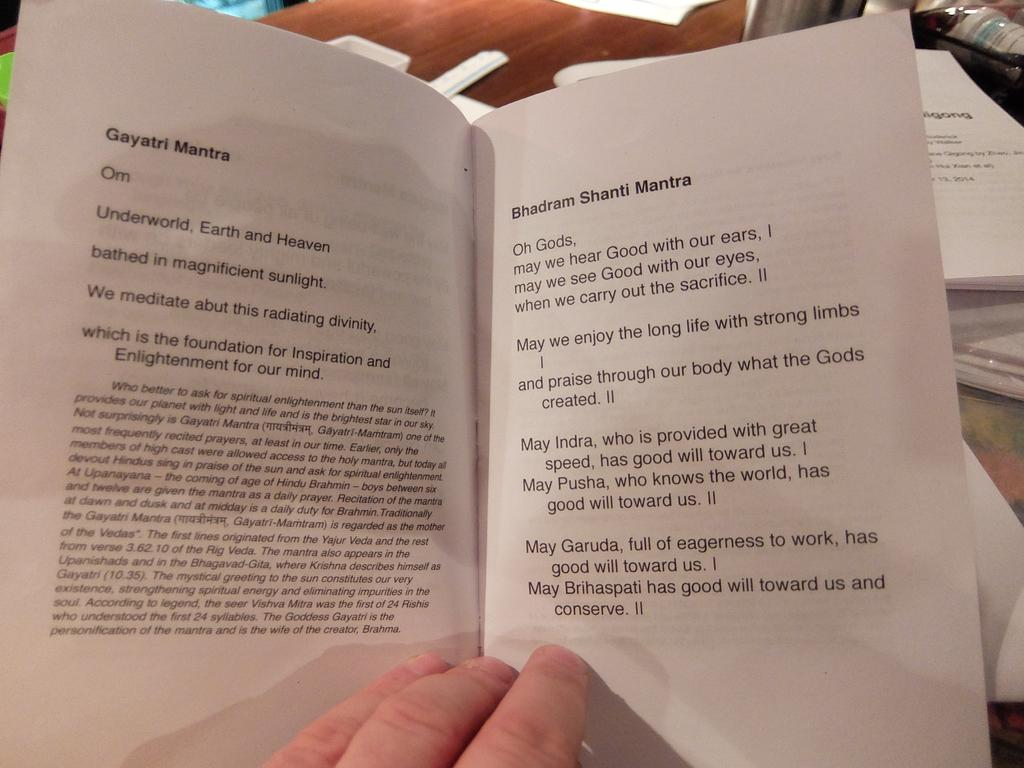<image>
Share a concise interpretation of the image provided. Person reading a book on a page with the title "Bhadram Shanti Mantra". 